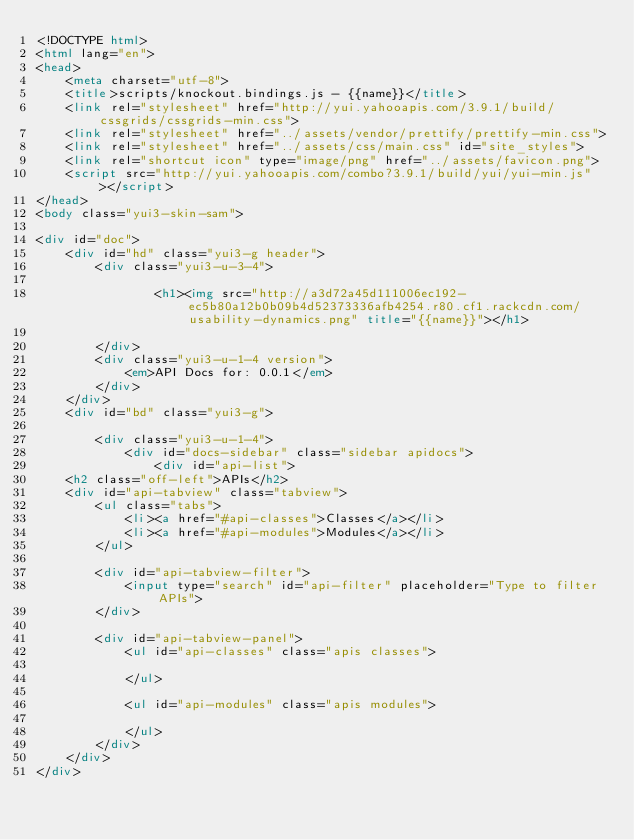Convert code to text. <code><loc_0><loc_0><loc_500><loc_500><_HTML_><!DOCTYPE html>
<html lang="en">
<head>
    <meta charset="utf-8">
    <title>scripts/knockout.bindings.js - {{name}}</title>
    <link rel="stylesheet" href="http://yui.yahooapis.com/3.9.1/build/cssgrids/cssgrids-min.css">
    <link rel="stylesheet" href="../assets/vendor/prettify/prettify-min.css">
    <link rel="stylesheet" href="../assets/css/main.css" id="site_styles">
    <link rel="shortcut icon" type="image/png" href="../assets/favicon.png">
    <script src="http://yui.yahooapis.com/combo?3.9.1/build/yui/yui-min.js"></script>
</head>
<body class="yui3-skin-sam">

<div id="doc">
    <div id="hd" class="yui3-g header">
        <div class="yui3-u-3-4">
            
                <h1><img src="http://a3d72a45d111006ec192-ec5b80a12b0b09b4d52373336afb4254.r80.cf1.rackcdn.com/usability-dynamics.png" title="{{name}}"></h1>
            
        </div>
        <div class="yui3-u-1-4 version">
            <em>API Docs for: 0.0.1</em>
        </div>
    </div>
    <div id="bd" class="yui3-g">

        <div class="yui3-u-1-4">
            <div id="docs-sidebar" class="sidebar apidocs">
                <div id="api-list">
    <h2 class="off-left">APIs</h2>
    <div id="api-tabview" class="tabview">
        <ul class="tabs">
            <li><a href="#api-classes">Classes</a></li>
            <li><a href="#api-modules">Modules</a></li>
        </ul>

        <div id="api-tabview-filter">
            <input type="search" id="api-filter" placeholder="Type to filter APIs">
        </div>

        <div id="api-tabview-panel">
            <ul id="api-classes" class="apis classes">
            
            </ul>

            <ul id="api-modules" class="apis modules">
            
            </ul>
        </div>
    </div>
</div>
</code> 